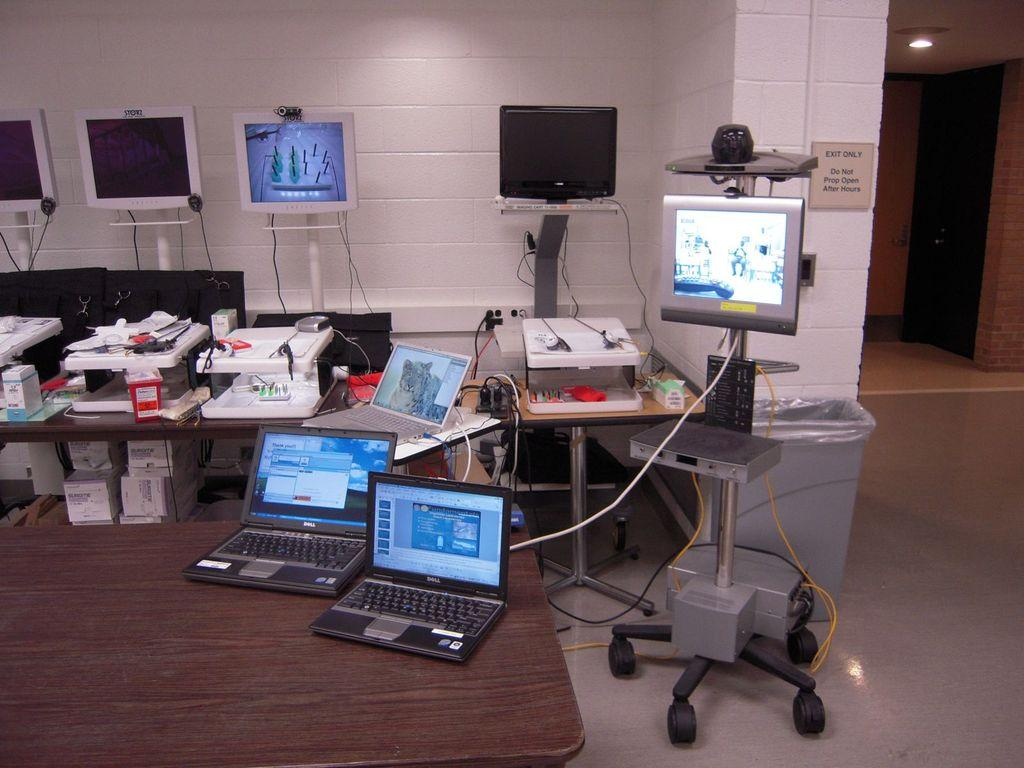What type of objects can be seen on the table in the image? There are electronic gadgets on the table in the image. What is attached to the wall in the image? There is a label attached to the wall in the image. What does the label say? The label is named "EXIT ONLY." How comfortable is the name of the label in the image? The name of the label, "EXIT ONLY," is not a physical object that can be described as comfortable or uncomfortable. 